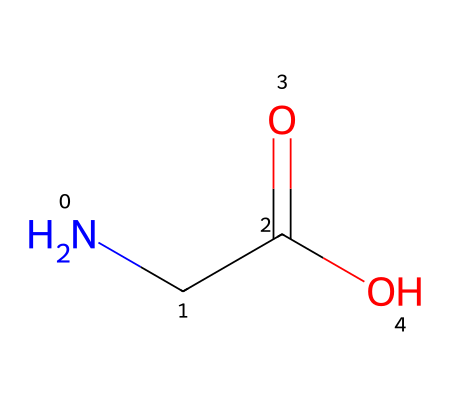How many carbon atoms are in beta-alanine? The SMILES notation lists NCC(=O)O, which indicates a total of 2 carbon atoms (C). Each ‘C’ in the structure represents one carbon atom.
Answer: 2 What functional group is present in beta-alanine? The chemical structure includes a carboxylic acid group (-COOH) indicated by the (-C(=O)O) portion of the SMILES. This confirms the presence of a functional group characteristic of carboxylic acids.
Answer: carboxylic acid What is the full name of the chemical represented by the SMILES provided? The SMILES code NCC(=O)O corresponds to beta-alanine, a beta-amino acid with a specific structure.
Answer: beta-alanine What role does beta-alanine serve in muscle endurance? Beta-alanine acts as a precursor to carnosine, a dipeptide that helps buffer acid in muscles during high-intensity exercise, thus enhancing endurance.
Answer: buffering agent How many nitrogen atoms are in beta-alanine? In the SMILES notation, the presence of 'N' indicates there is one nitrogen atom present in the structure of beta-alanine.
Answer: 1 What is the molecular formula of beta-alanine? The molecular formula can be derived from the counts of each atom present in the structure: 3 Carbons (C), 7 Hydrogens (H), 1 Nitrogen (N), and 2 Oxygens (O), giving C3H7NO2.
Answer: C3H7NO2 